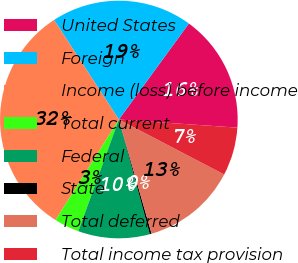<chart> <loc_0><loc_0><loc_500><loc_500><pie_chart><fcel>United States<fcel>Foreign<fcel>Income (loss) before income<fcel>Total current<fcel>Federal<fcel>State<fcel>Total deferred<fcel>Total income tax provision<nl><fcel>16.06%<fcel>19.22%<fcel>31.87%<fcel>3.41%<fcel>9.73%<fcel>0.25%<fcel>12.9%<fcel>6.57%<nl></chart> 